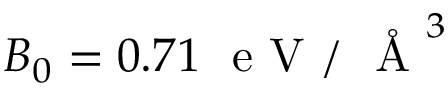<formula> <loc_0><loc_0><loc_500><loc_500>B _ { 0 } = 0 . 7 1 \ e V / \AA ^ { 3 }</formula> 